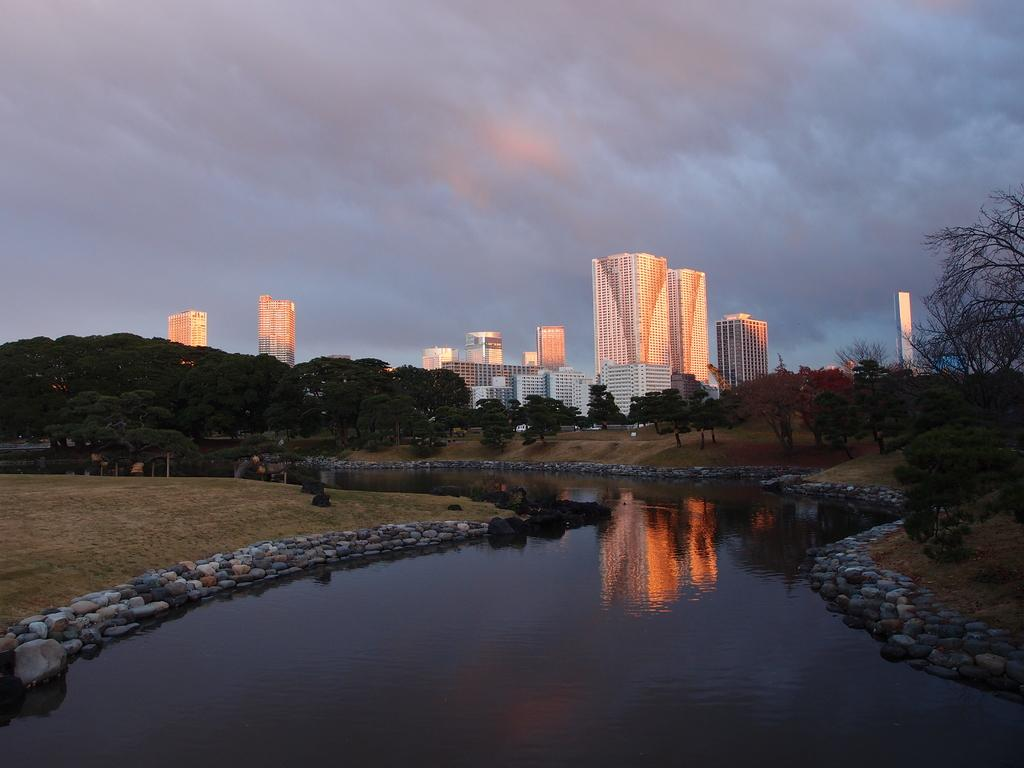What is one of the natural elements present in the image? There is water in the image. What type of terrain can be seen in the image? There are stones, grass, plants, and trees in the image. Are there any man-made structures visible in the image? Yes, there are buildings in the image. What is visible in the background of the image? The sky is visible in the image. What type of fruit is being printed on the position of the tree in the image? There is no fruit being printed on any position in the image, as it does not involve any printed material or fruit. 